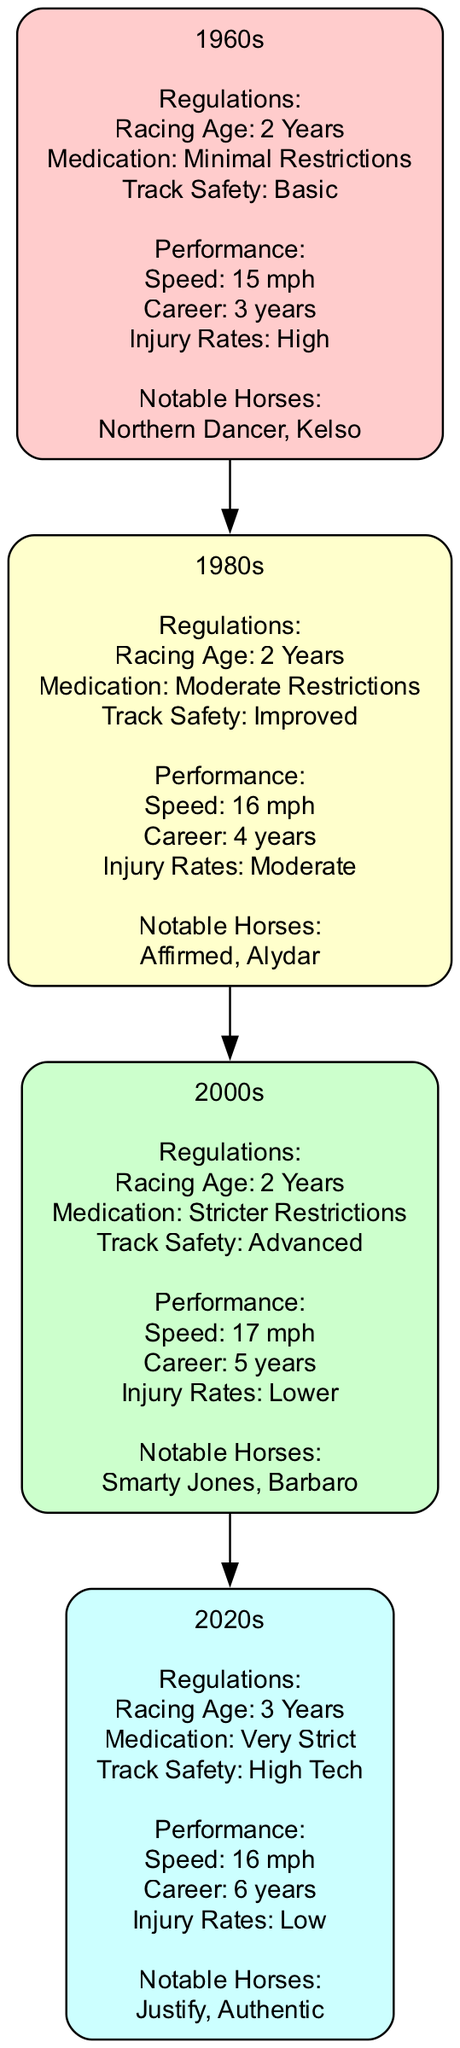What is the speed record for the 2000s generation? The diagram shows that the speed record for the 2000s generation is "17 mph". This information can be found in the performance details corresponding to that generation.
Answer: 17 mph What was the injury rate in the 1980s? According to the diagram, the injury rate for the 1980s generation is "Moderate". This is located in the horse performance section for that specific generation.
Answer: Moderate How many generations are represented in the diagram? The diagram lists a total of four generations: 1960s, 1980s, 2000s, and 2020s. Counting each listed generation gives the total number of generations represented as four.
Answer: 4 What notable horses are associated with the 2020s generation? The notable horses for the 2020s generation listed in the diagram are "Justify" and "Authentic". This information can be easily found in the notable horses section of that generation.
Answer: Justify, Authentic Which generation has the highest average career longevity? The diagram indicates that the 2020s generation has an average career longevity of "6 years", which is higher than all previous generations. By comparing the average career longevity across each generation, this can be determined.
Answer: 6 years What impact did stricter medication usage have on performance from the 1980s to the 2000s? When comparing the medication usage from the 1980s ("Moderate Restrictions") to the 2000s ("Stricter Restrictions"), the performance improved as indicated by the increase in speed records from "16 mph" to "17 mph", alongside lower injury rates. This demonstrates that stricter medication usage correlates with enhanced performance outcomes.
Answer: Improved performance How did the racing age change from the 2000s to the 2020s? The diagram indicates that the racing age shifted from "2 Years" in the 2000s to "3 Years" in the 2020s. This is specifically stated in the regulations section for both generations, showing a change in the rules governing racing eligibility.
Answer: 3 Years Which generation had the lowest injury rates? The diagram specifies that the 2020s generation has the injury rates marked as "Low", which is the lowest amongst all the generations presented. This can be verified by looking at the injury rates for each generation.
Answer: Low 